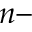<formula> <loc_0><loc_0><loc_500><loc_500>n -</formula> 